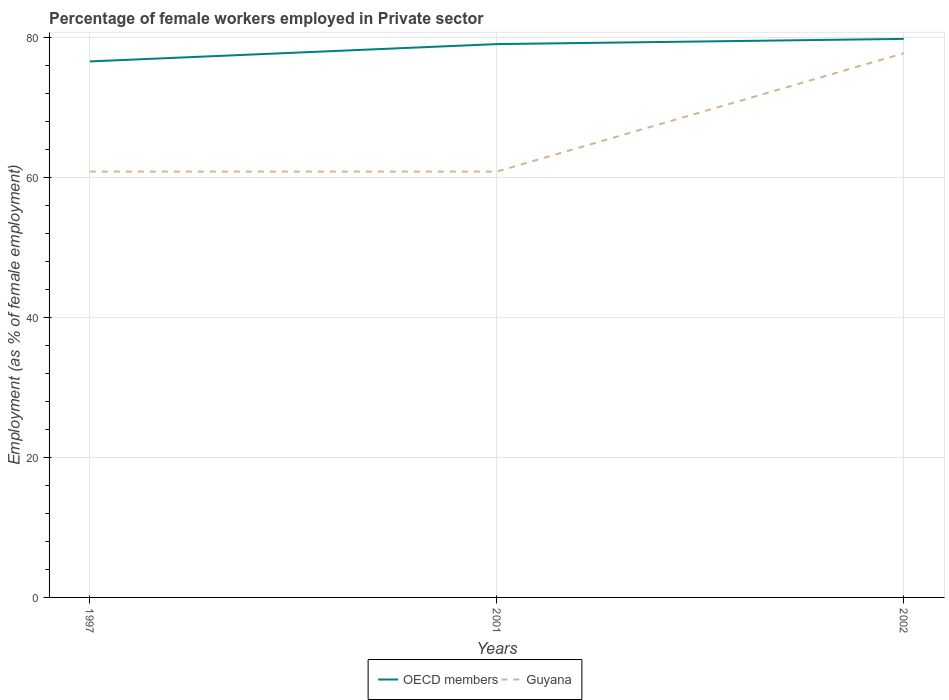Does the line corresponding to OECD members intersect with the line corresponding to Guyana?
Keep it short and to the point. No. Across all years, what is the maximum percentage of females employed in Private sector in OECD members?
Your response must be concise. 76.53. In which year was the percentage of females employed in Private sector in OECD members maximum?
Keep it short and to the point. 1997. What is the total percentage of females employed in Private sector in OECD members in the graph?
Your answer should be very brief. -0.74. What is the difference between the highest and the second highest percentage of females employed in Private sector in Guyana?
Make the answer very short. 16.9. What is the difference between the highest and the lowest percentage of females employed in Private sector in OECD members?
Your answer should be compact. 2. Is the percentage of females employed in Private sector in OECD members strictly greater than the percentage of females employed in Private sector in Guyana over the years?
Your response must be concise. No. How many lines are there?
Your answer should be very brief. 2. Does the graph contain any zero values?
Give a very brief answer. No. How are the legend labels stacked?
Your answer should be very brief. Horizontal. What is the title of the graph?
Ensure brevity in your answer.  Percentage of female workers employed in Private sector. What is the label or title of the X-axis?
Offer a terse response. Years. What is the label or title of the Y-axis?
Your answer should be compact. Employment (as % of female employment). What is the Employment (as % of female employment) of OECD members in 1997?
Make the answer very short. 76.53. What is the Employment (as % of female employment) in Guyana in 1997?
Provide a short and direct response. 60.8. What is the Employment (as % of female employment) of OECD members in 2001?
Your answer should be compact. 79. What is the Employment (as % of female employment) of Guyana in 2001?
Your response must be concise. 60.8. What is the Employment (as % of female employment) of OECD members in 2002?
Give a very brief answer. 79.74. What is the Employment (as % of female employment) in Guyana in 2002?
Provide a short and direct response. 77.7. Across all years, what is the maximum Employment (as % of female employment) in OECD members?
Your response must be concise. 79.74. Across all years, what is the maximum Employment (as % of female employment) in Guyana?
Offer a very short reply. 77.7. Across all years, what is the minimum Employment (as % of female employment) in OECD members?
Offer a terse response. 76.53. Across all years, what is the minimum Employment (as % of female employment) in Guyana?
Keep it short and to the point. 60.8. What is the total Employment (as % of female employment) in OECD members in the graph?
Offer a terse response. 235.27. What is the total Employment (as % of female employment) in Guyana in the graph?
Make the answer very short. 199.3. What is the difference between the Employment (as % of female employment) in OECD members in 1997 and that in 2001?
Ensure brevity in your answer.  -2.47. What is the difference between the Employment (as % of female employment) of Guyana in 1997 and that in 2001?
Make the answer very short. 0. What is the difference between the Employment (as % of female employment) in OECD members in 1997 and that in 2002?
Your answer should be compact. -3.22. What is the difference between the Employment (as % of female employment) in Guyana in 1997 and that in 2002?
Your answer should be compact. -16.9. What is the difference between the Employment (as % of female employment) of OECD members in 2001 and that in 2002?
Offer a very short reply. -0.74. What is the difference between the Employment (as % of female employment) of Guyana in 2001 and that in 2002?
Ensure brevity in your answer.  -16.9. What is the difference between the Employment (as % of female employment) of OECD members in 1997 and the Employment (as % of female employment) of Guyana in 2001?
Ensure brevity in your answer.  15.73. What is the difference between the Employment (as % of female employment) in OECD members in 1997 and the Employment (as % of female employment) in Guyana in 2002?
Give a very brief answer. -1.17. What is the difference between the Employment (as % of female employment) in OECD members in 2001 and the Employment (as % of female employment) in Guyana in 2002?
Give a very brief answer. 1.3. What is the average Employment (as % of female employment) of OECD members per year?
Your response must be concise. 78.42. What is the average Employment (as % of female employment) of Guyana per year?
Your response must be concise. 66.43. In the year 1997, what is the difference between the Employment (as % of female employment) of OECD members and Employment (as % of female employment) of Guyana?
Your answer should be very brief. 15.73. In the year 2001, what is the difference between the Employment (as % of female employment) in OECD members and Employment (as % of female employment) in Guyana?
Keep it short and to the point. 18.2. In the year 2002, what is the difference between the Employment (as % of female employment) in OECD members and Employment (as % of female employment) in Guyana?
Your answer should be compact. 2.04. What is the ratio of the Employment (as % of female employment) of OECD members in 1997 to that in 2001?
Offer a very short reply. 0.97. What is the ratio of the Employment (as % of female employment) of Guyana in 1997 to that in 2001?
Ensure brevity in your answer.  1. What is the ratio of the Employment (as % of female employment) of OECD members in 1997 to that in 2002?
Make the answer very short. 0.96. What is the ratio of the Employment (as % of female employment) of Guyana in 1997 to that in 2002?
Your answer should be compact. 0.78. What is the ratio of the Employment (as % of female employment) in OECD members in 2001 to that in 2002?
Keep it short and to the point. 0.99. What is the ratio of the Employment (as % of female employment) of Guyana in 2001 to that in 2002?
Offer a terse response. 0.78. What is the difference between the highest and the second highest Employment (as % of female employment) of OECD members?
Ensure brevity in your answer.  0.74. What is the difference between the highest and the lowest Employment (as % of female employment) in OECD members?
Offer a very short reply. 3.22. What is the difference between the highest and the lowest Employment (as % of female employment) in Guyana?
Your answer should be very brief. 16.9. 